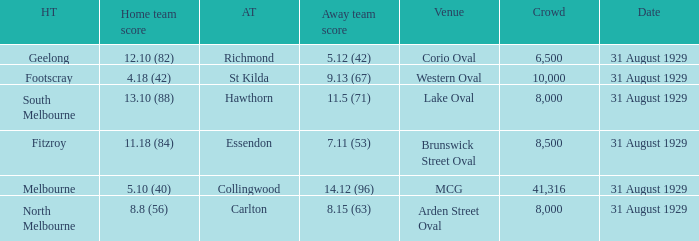What was the score of the home team when the away team scored 14.12 (96)? 5.10 (40). Help me parse the entirety of this table. {'header': ['HT', 'Home team score', 'AT', 'Away team score', 'Venue', 'Crowd', 'Date'], 'rows': [['Geelong', '12.10 (82)', 'Richmond', '5.12 (42)', 'Corio Oval', '6,500', '31 August 1929'], ['Footscray', '4.18 (42)', 'St Kilda', '9.13 (67)', 'Western Oval', '10,000', '31 August 1929'], ['South Melbourne', '13.10 (88)', 'Hawthorn', '11.5 (71)', 'Lake Oval', '8,000', '31 August 1929'], ['Fitzroy', '11.18 (84)', 'Essendon', '7.11 (53)', 'Brunswick Street Oval', '8,500', '31 August 1929'], ['Melbourne', '5.10 (40)', 'Collingwood', '14.12 (96)', 'MCG', '41,316', '31 August 1929'], ['North Melbourne', '8.8 (56)', 'Carlton', '8.15 (63)', 'Arden Street Oval', '8,000', '31 August 1929']]} 